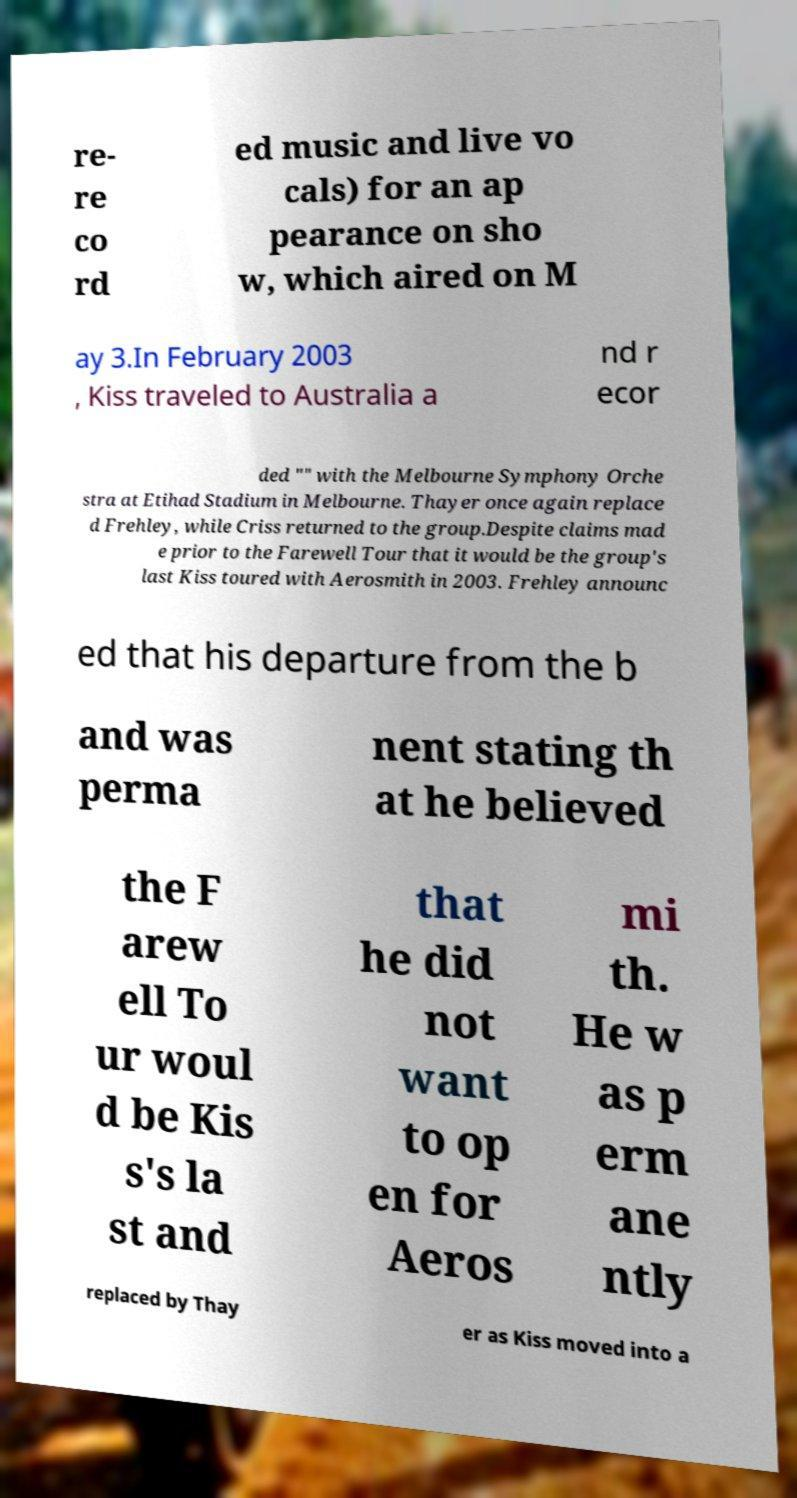Could you assist in decoding the text presented in this image and type it out clearly? re- re co rd ed music and live vo cals) for an ap pearance on sho w, which aired on M ay 3.In February 2003 , Kiss traveled to Australia a nd r ecor ded "" with the Melbourne Symphony Orche stra at Etihad Stadium in Melbourne. Thayer once again replace d Frehley, while Criss returned to the group.Despite claims mad e prior to the Farewell Tour that it would be the group's last Kiss toured with Aerosmith in 2003. Frehley announc ed that his departure from the b and was perma nent stating th at he believed the F arew ell To ur woul d be Kis s's la st and that he did not want to op en for Aeros mi th. He w as p erm ane ntly replaced by Thay er as Kiss moved into a 